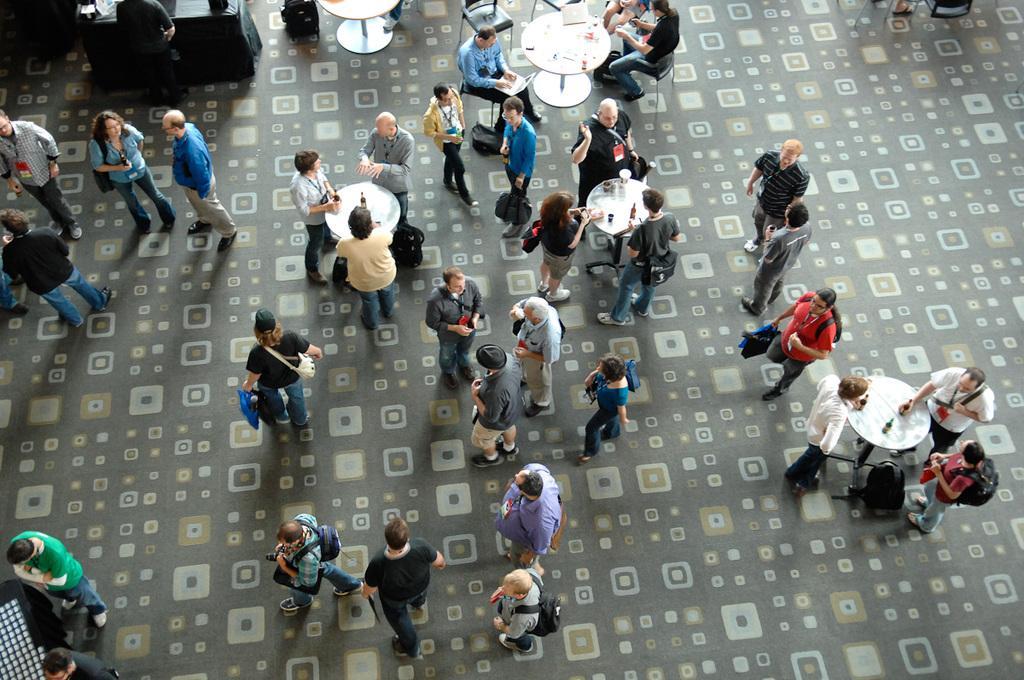Describe this image in one or two sentences. In this image I can see there are few people carrying bags, few are standing at the table and drinking wine, few are sitting on the chair and operating a laptop. 